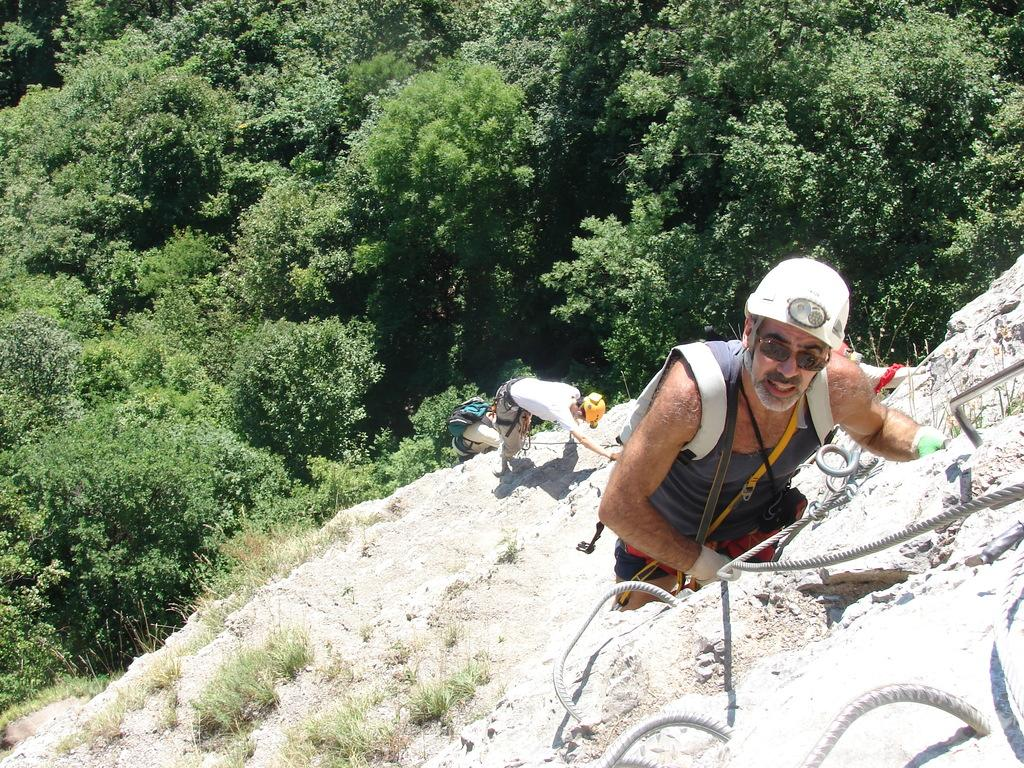Who is the main subject in the image? There is a man in the image. What is near the man? There are ropes near the man. How many people are behind the man? There are three persons behind the man. What type of terrain is visible in the image? There is grass visible in the image. What can be seen in the background of the image? There are trees in the background of the image. What type of chin is visible on the man in the image? There is no chin visible on the man in the image, as the image does not show the man's face. 